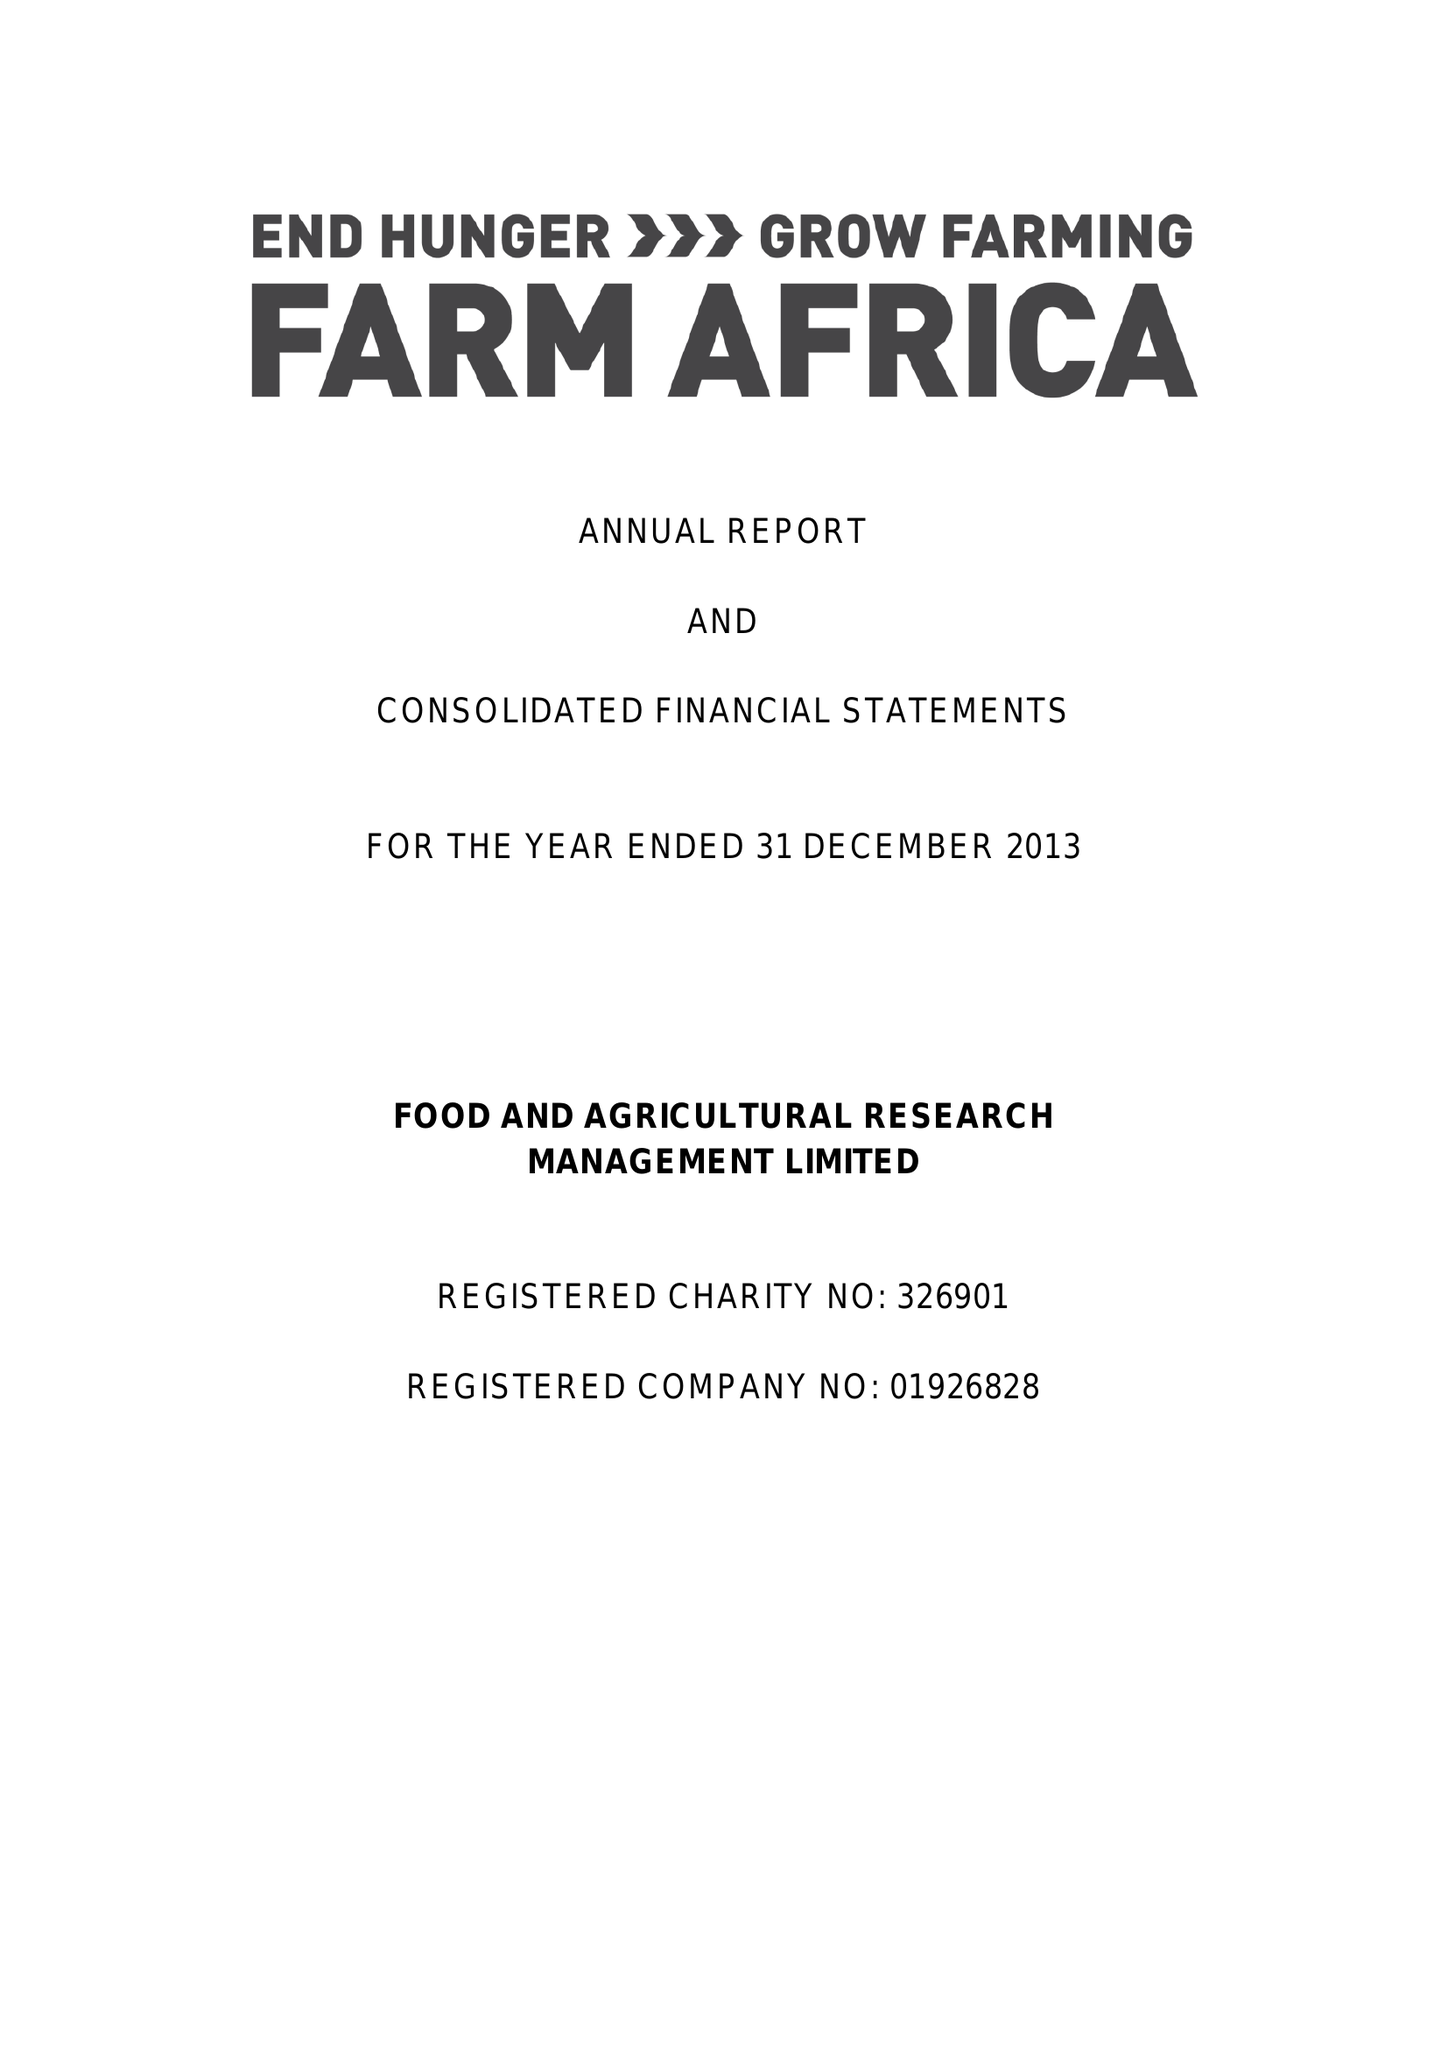What is the value for the address__post_town?
Answer the question using a single word or phrase. LONDON 